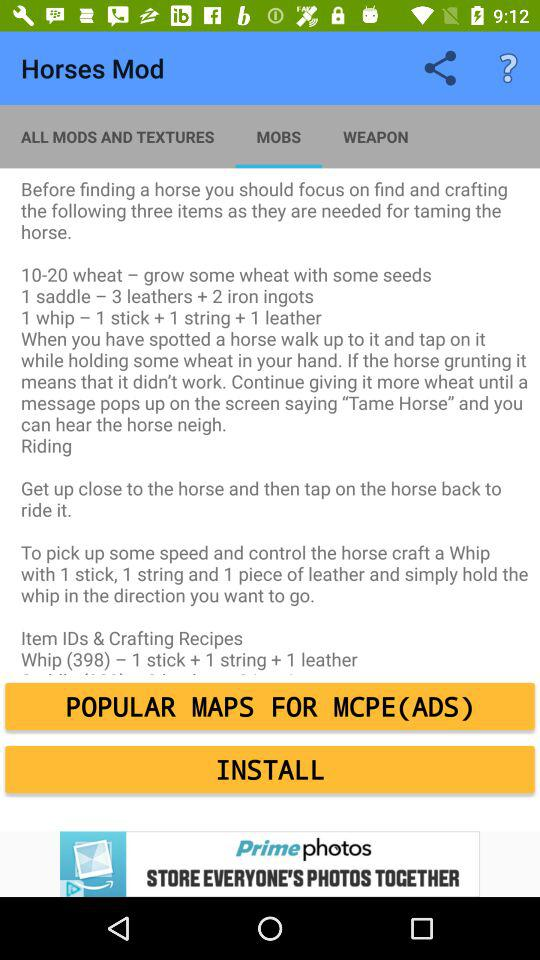How many items are needed to tame a horse?
Answer the question using a single word or phrase. 3 